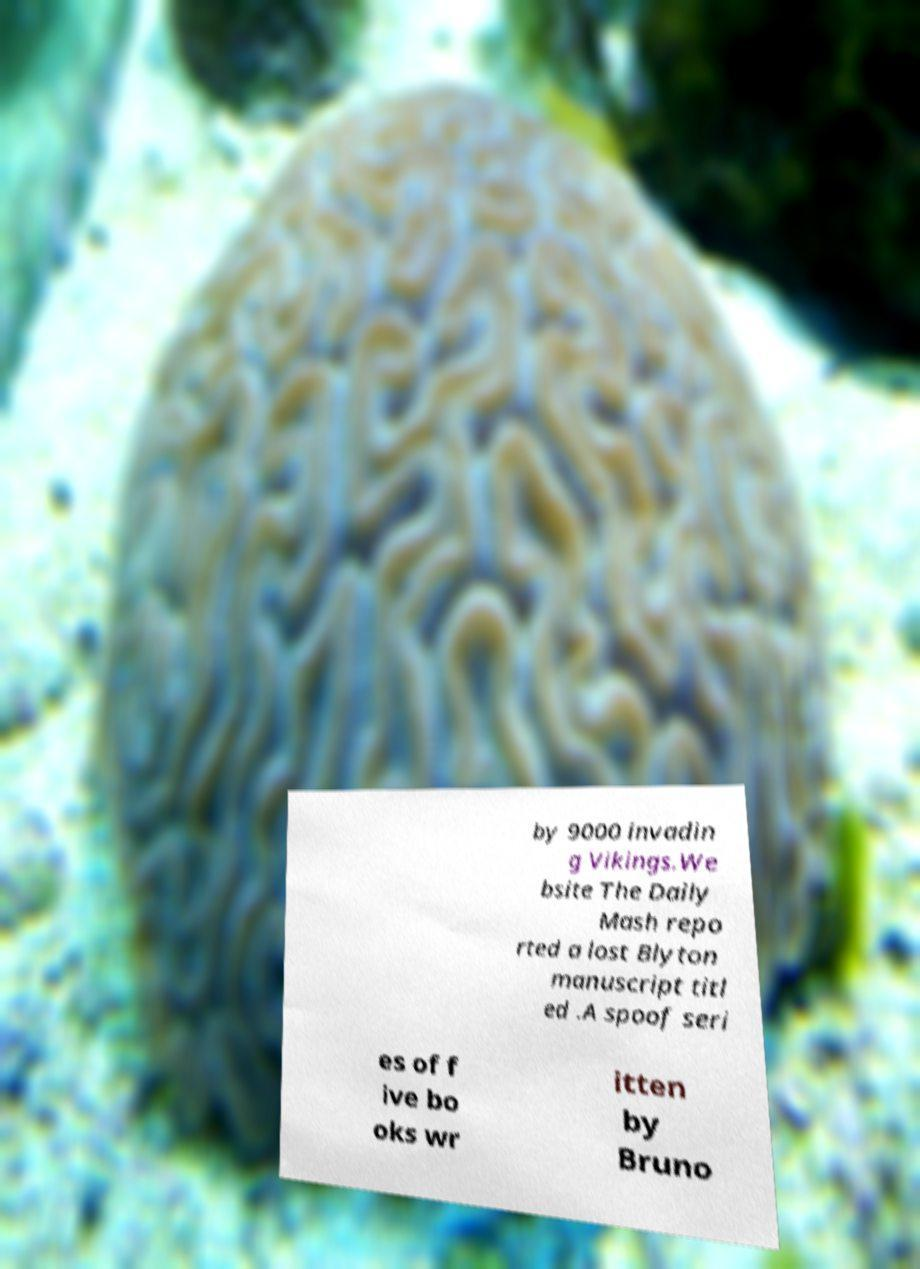Can you accurately transcribe the text from the provided image for me? by 9000 invadin g Vikings.We bsite The Daily Mash repo rted a lost Blyton manuscript titl ed .A spoof seri es of f ive bo oks wr itten by Bruno 